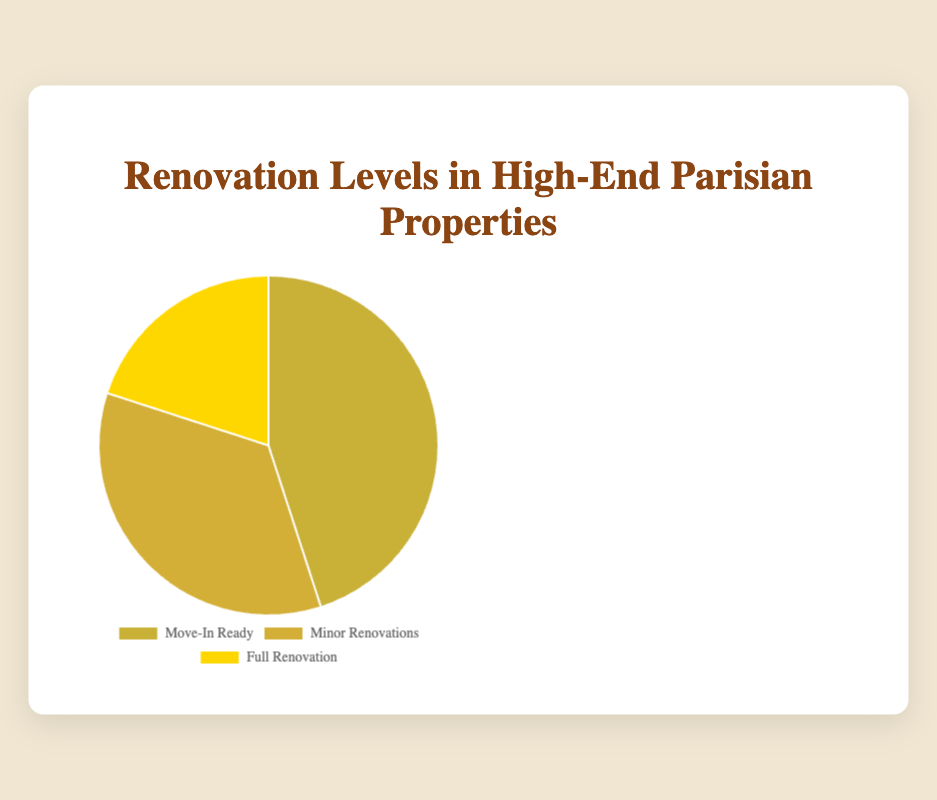What is the percentage share of properties requiring minor renovations? The pie chart shows three categories: Move-In Ready, Minor Renovations, and Full Renovation. By looking at the section labeled 'Minor Renovations,' you can see it covers 35% of the chart.
Answer: 35% What is the combined share of Move-In Ready and Full Renovation properties? The chart shows 45% for Move-In Ready and 20% for Full Renovation. Adding these two percentages together gives 45% + 20% = 65%.
Answer: 65% How does the proportion of Move-In Ready properties compare to those requiring full renovation? The Move-In Ready properties have a share of 45%, while Full Renovation properties have a share of 20%. Comparing these percentages, Move-In Ready properties have a higher share.
Answer: Move-In Ready has a higher share Which category has the least share in the pie chart? The pie chart segments show Move-In Ready with 45%, Minor Renovations with 35%, and Full Renovation with 20%. The smallest share is for Full Renovation.
Answer: Full Renovation What is the percentage difference between properties requiring minor renovations and those needing full renovation? The pie chart shows that Minor Renovations have a share of 35% and Full Renovation has 20%. The difference is 35% - 20% = 15%.
Answer: 15% What percentage of properties do not require full renovations? To find this, subtract the percentage of Full Renovation properties from 100%. The share for Full Renovation is 20%, so 100% - 20% = 80%.
Answer: 80% Which property category constitutes nearly half of all high-end Parisian properties? Referring to the pie chart, the Move-In Ready category comprises 45%, which is nearly half.
Answer: Move-In Ready Can you identify the color associated with Move-In Ready properties? In the pie chart, the Move-In Ready segment is colored differently from the others. It is represented in a gold-like color.
Answer: Gold-like What is the average share of properties that are considered Move-In Ready and those requiring minor renovations? The shares for Move-In Ready and Minor Renovations are 45% and 35%, respectively. To find the average, (45% + 35%) / 2 = 40%.
Answer: 40% Which segment is represented with the third largest portion in the pie chart? Observing the pie chart, the segments are ordered by percentage as 45%, 35%, and 20%. The third largest portion is for Full Renovation.
Answer: Full Renovation 